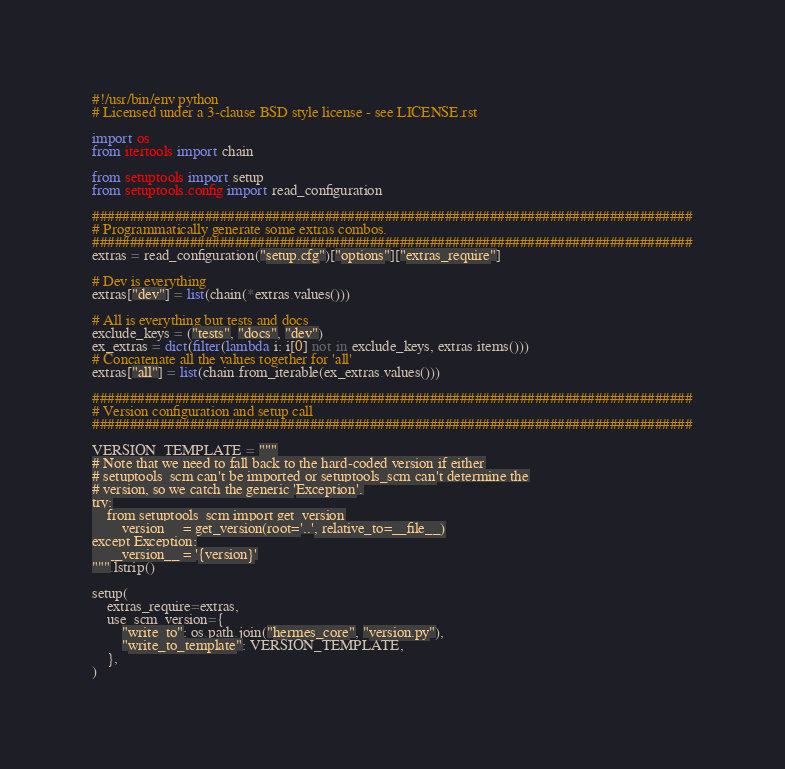<code> <loc_0><loc_0><loc_500><loc_500><_Python_>#!/usr/bin/env python
# Licensed under a 3-clause BSD style license - see LICENSE.rst

import os
from itertools import chain

from setuptools import setup
from setuptools.config import read_configuration

################################################################################
# Programmatically generate some extras combos.
################################################################################
extras = read_configuration("setup.cfg")["options"]["extras_require"]

# Dev is everything
extras["dev"] = list(chain(*extras.values()))

# All is everything but tests and docs
exclude_keys = ("tests", "docs", "dev")
ex_extras = dict(filter(lambda i: i[0] not in exclude_keys, extras.items()))
# Concatenate all the values together for 'all'
extras["all"] = list(chain.from_iterable(ex_extras.values()))

################################################################################
# Version configuration and setup call
################################################################################

VERSION_TEMPLATE = """
# Note that we need to fall back to the hard-coded version if either
# setuptools_scm can't be imported or setuptools_scm can't determine the
# version, so we catch the generic 'Exception'.
try:
    from setuptools_scm import get_version
    __version__ = get_version(root='..', relative_to=__file__)
except Exception:
    __version__ = '{version}'
""".lstrip()

setup(
    extras_require=extras,
    use_scm_version={
        "write_to": os.path.join("hermes_core", "version.py"),
        "write_to_template": VERSION_TEMPLATE,
    },
)
</code> 